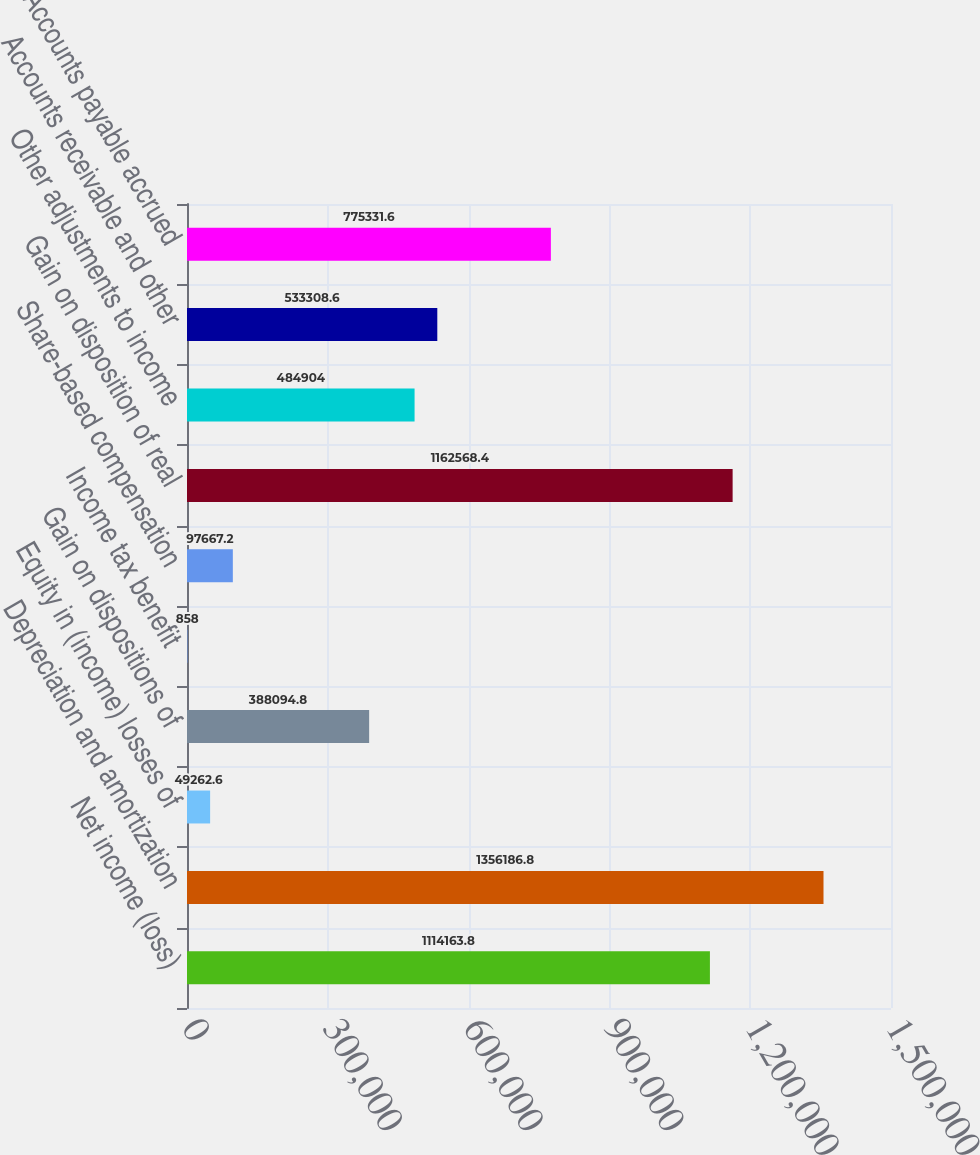<chart> <loc_0><loc_0><loc_500><loc_500><bar_chart><fcel>Net income (loss)<fcel>Depreciation and amortization<fcel>Equity in (income) losses of<fcel>Gain on dispositions of<fcel>Income tax benefit<fcel>Share-based compensation<fcel>Gain on disposition of real<fcel>Other adjustments to income<fcel>Accounts receivable and other<fcel>Accounts payable accrued<nl><fcel>1.11416e+06<fcel>1.35619e+06<fcel>49262.6<fcel>388095<fcel>858<fcel>97667.2<fcel>1.16257e+06<fcel>484904<fcel>533309<fcel>775332<nl></chart> 